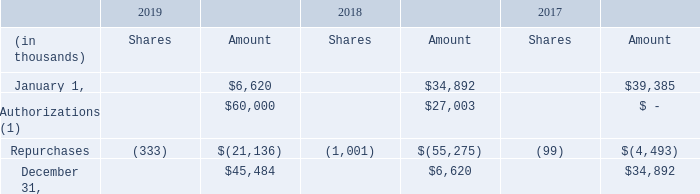Stock repurchases
(1) On March 15, 2019, the Company announced that the Board of Directors extended the expiration date of the current stock repurchase program to June 30, 2020 and increased the amount of common stock the Company is authorized to repurchase by $60 million.
When did the company announce that the Board of Directors extended the expiration date of the current stock repurchase program? March 15, 2019. What were the amounts that the company is authorised to repurchase in 2019 and 2018 respectively?
Answer scale should be: thousand. $60,000, $27,003. What were the respective amounts of stock repurchases made by the company as at January 1, 2018 and 2019 respectively?
Answer scale should be: thousand. $34,892, $6,620. What is the value of stock repurchases as at January 1, 2019 as a percentage of the stock repurchases as at January 1, 2018?
Answer scale should be: percent. 6,620/34,892 
Answer: 18.97. What is the average stock repurchases as at January 1, 2017 and 2018?
Answer scale should be: thousand. (39,385 + 34,892)/2 
Answer: 37138.5. What is the percentage change in stock repurchases authorizations made in 2018 and 2019?
Answer scale should be: percent. (60,000 - 27,003)/27,003 
Answer: 122.2. 